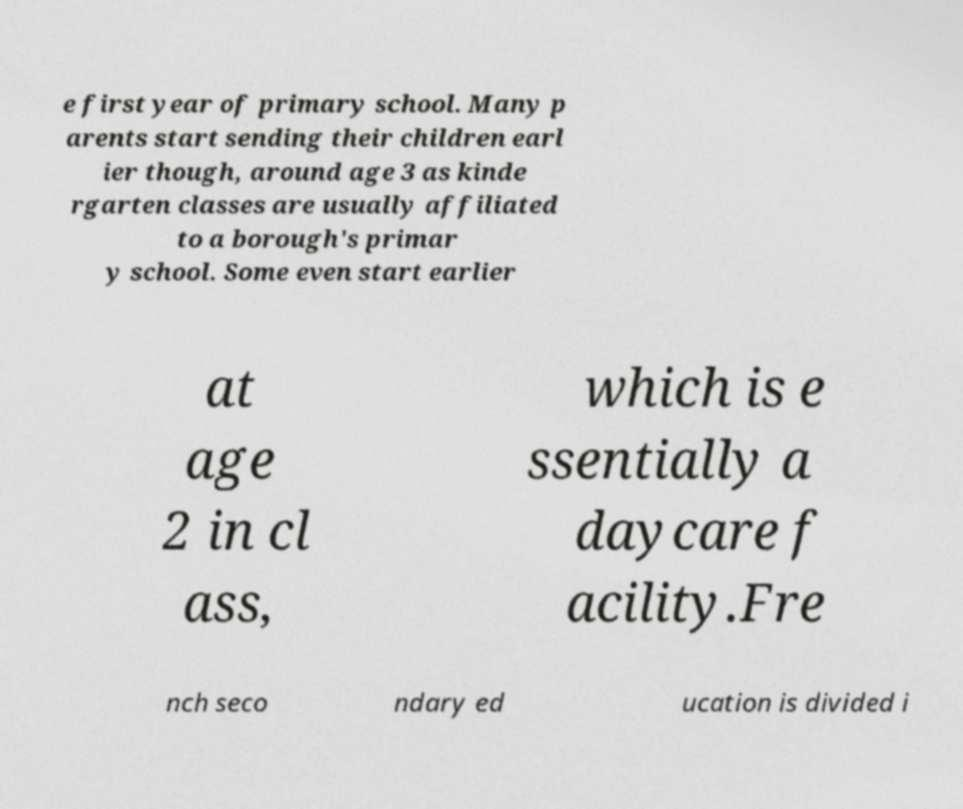Could you assist in decoding the text presented in this image and type it out clearly? e first year of primary school. Many p arents start sending their children earl ier though, around age 3 as kinde rgarten classes are usually affiliated to a borough's primar y school. Some even start earlier at age 2 in cl ass, which is e ssentially a daycare f acility.Fre nch seco ndary ed ucation is divided i 